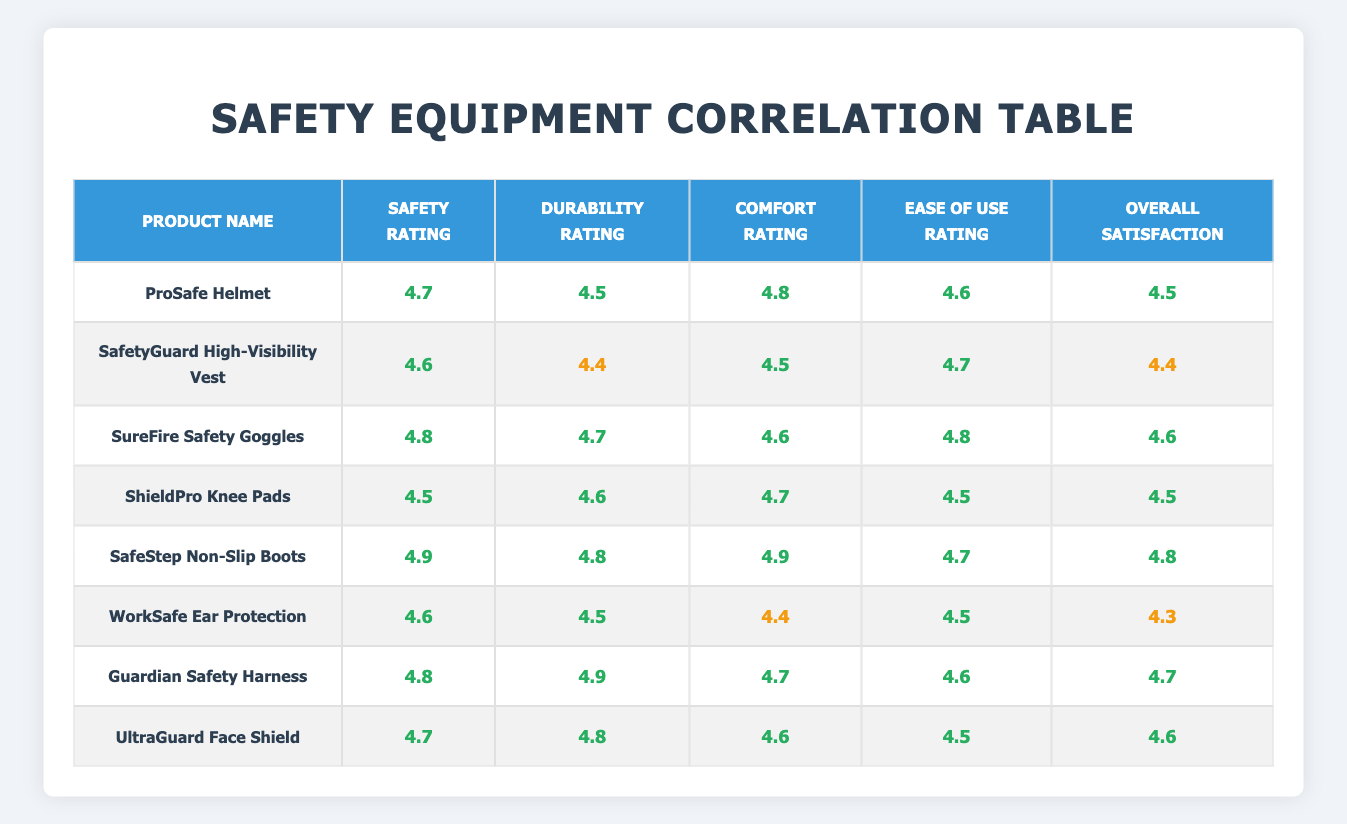What is the highest safety rating among the products? The highest safety rating in the table is identified by examining the safety ratings column. The value of 4.9 is found as the highest rating for the SafeStep Non-Slip Boots.
Answer: 4.9 Which product has the lowest overall satisfaction rating? To find the product with the lowest overall satisfaction rating, we look through the overall satisfaction column. The value of 4.3 is the lowest, which corresponds to the WorkSafe Ear Protection.
Answer: 4.3 What are the average durability and comfort ratings for the products? The average durability rating is calculated by summing the durability ratings (4.5 + 4.4 + 4.7 + 4.6 + 4.8 + 4.5 + 4.9 + 4.8 = 37.8) and dividing by the number of products (8), resulting in an average of 4.725. The average comfort rating is found similarly, resulting in a sum of (4.8 + 4.5 + 4.6 + 4.7 + 4.9 + 4.4 + 4.7 + 4.6 = 36.8) divided by 8, which gives an average of 4.6. Therefore, the averages are 4.725 and 4.6, respectively.
Answer: Durability: 4.725, Comfort: 4.6 Does any product have an overall satisfaction rating exceeding 4.7? Checking the overall satisfaction ratings column, the values 4.8 and 4.7 are present for SafeStep Non-Slip Boots and Guardian Safety Harness, respectively. Thus, there are products with ratings above 4.7.
Answer: Yes Which product has both the highest safety and overall satisfaction ratings? By reviewing the table, we see that the SafeStep Non-Slip Boots have a safety rating of 4.9 and an overall satisfaction rating of 4.8. Therefore, it has the highest in both categories.
Answer: SafeStep Non-Slip Boots What is the difference in overall satisfaction ratings between the highest and lowest rated products? The highest overall satisfaction rating is 4.8 (SafeStep Non-Slip Boots) and the lowest is 4.3 (WorkSafe Ear Protection). The difference is calculated as 4.8 - 4.3 = 0.5.
Answer: 0.5 Which product has the highest ease of use rating? The ease of use ratings are compared across the table, with the highest value being 4.8 for both SureFire Safety Goggles and Guardian Safety Harness, indicating they share the top rating in this category.
Answer: SureFire Safety Goggles and Guardian Safety Harness Are the comfort ratings for all products above 4.4? Looking at the comfort ratings, all values are verified: 4.8, 4.5, 4.6, 4.7, 4.9, 4.4, 4.7, and 4.6. Since one is equal to 4.4, the answer is affirmed as true.
Answer: Yes 